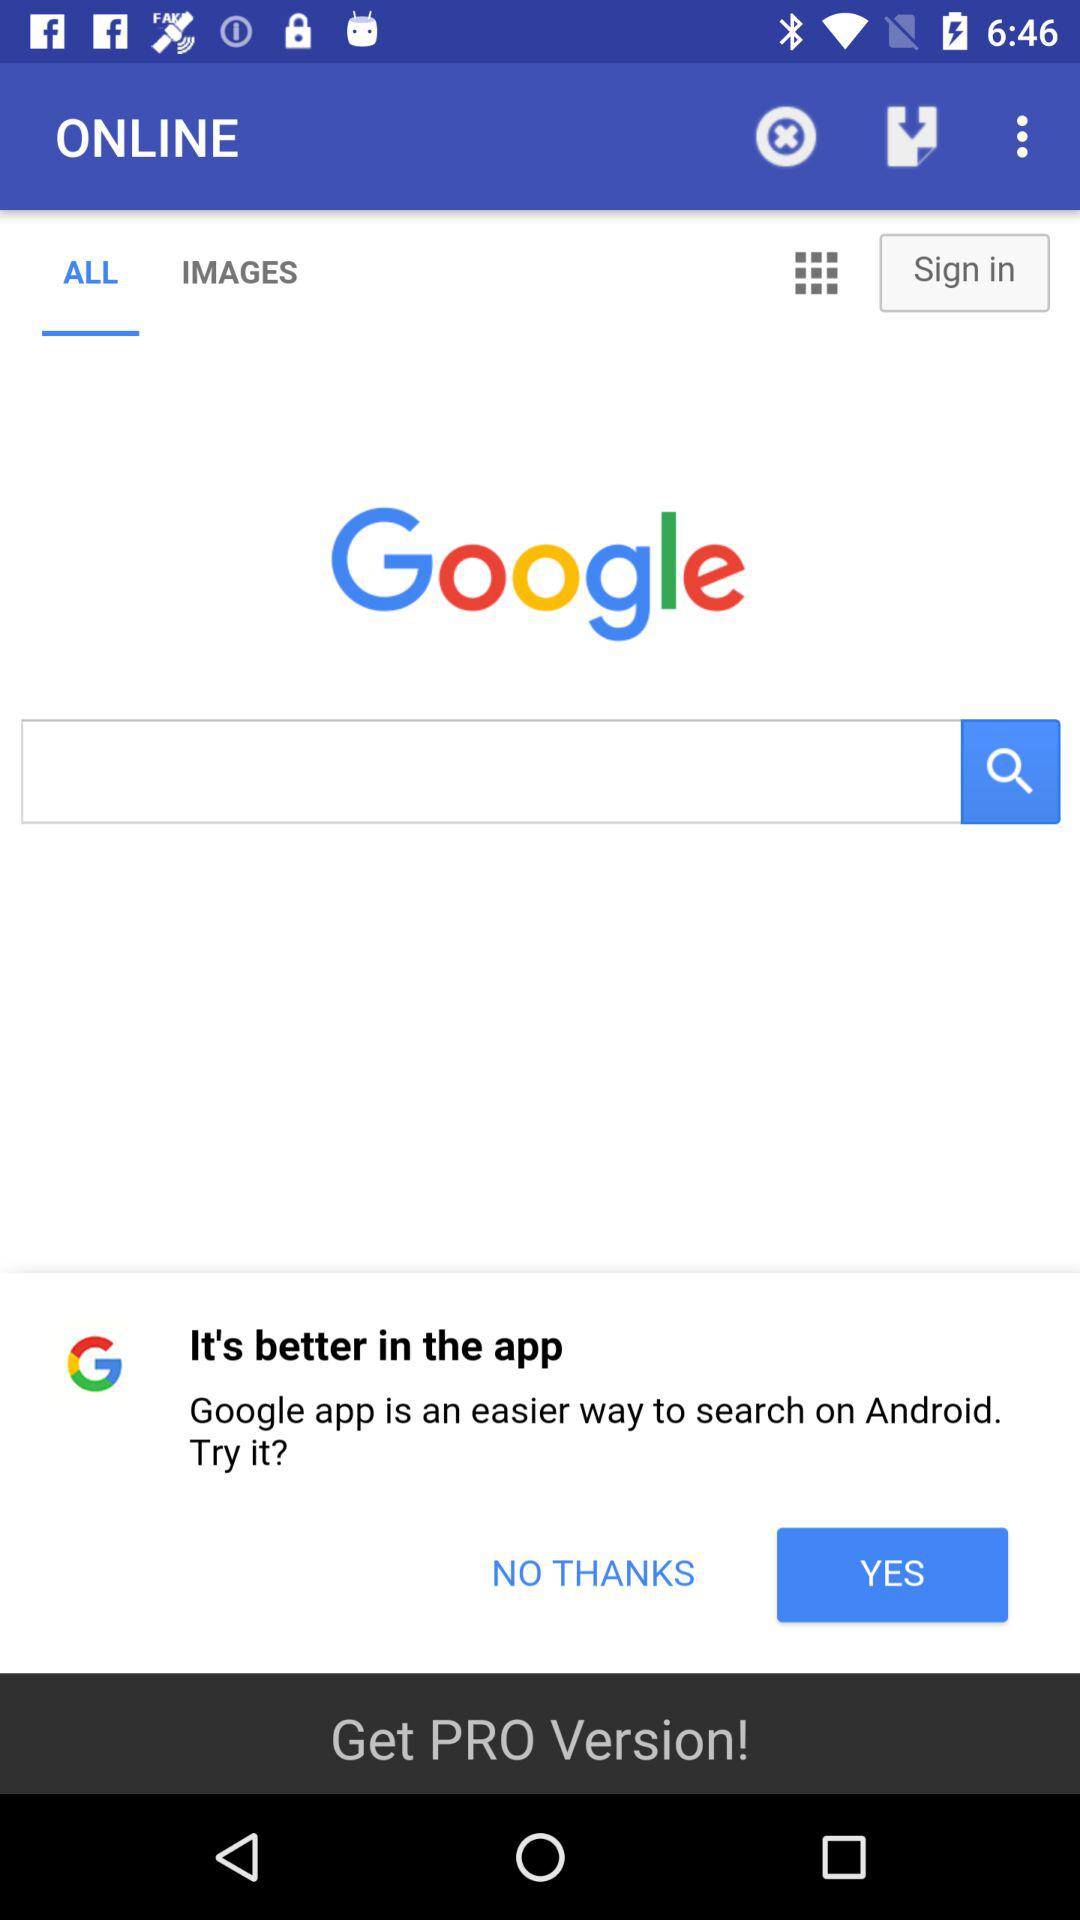Is the "PRO" version selected?
When the provided information is insufficient, respond with <no answer>. <no answer> 